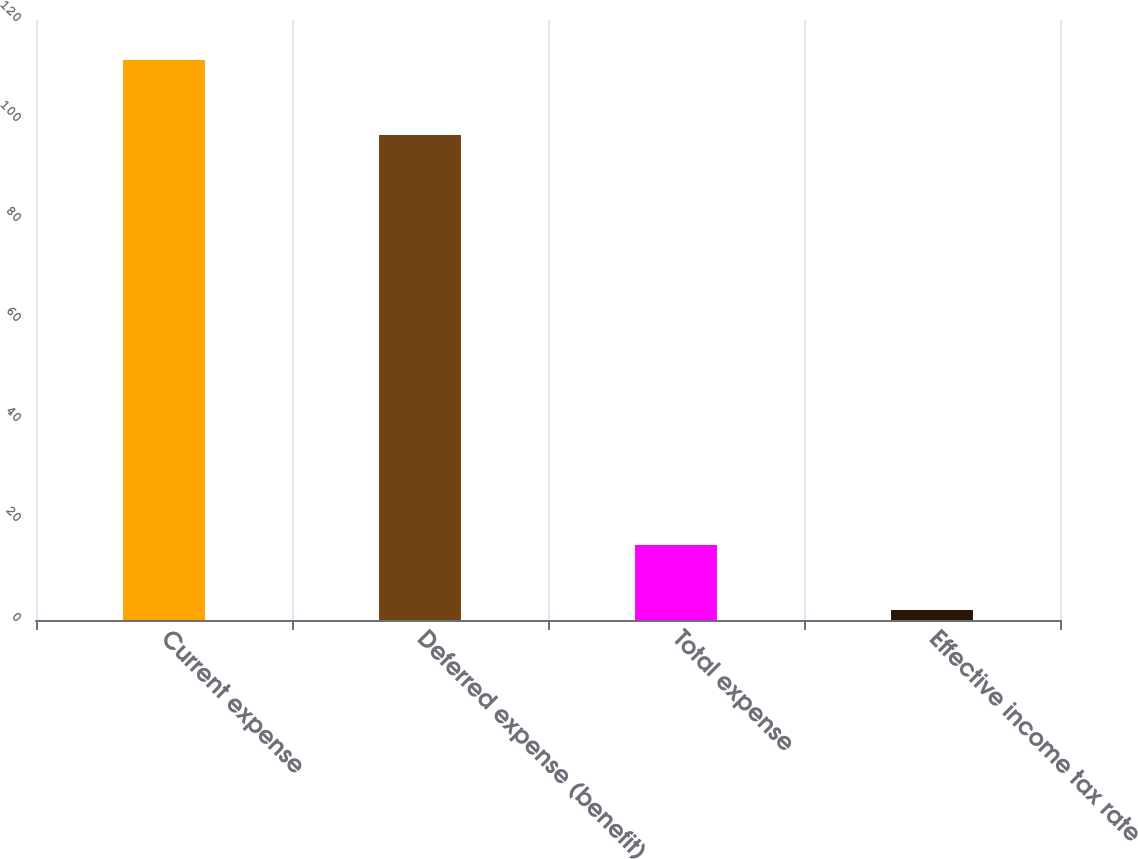<chart> <loc_0><loc_0><loc_500><loc_500><bar_chart><fcel>Current expense<fcel>Deferred expense (benefit)<fcel>Total expense<fcel>Effective income tax rate<nl><fcel>112<fcel>97<fcel>15<fcel>2<nl></chart> 